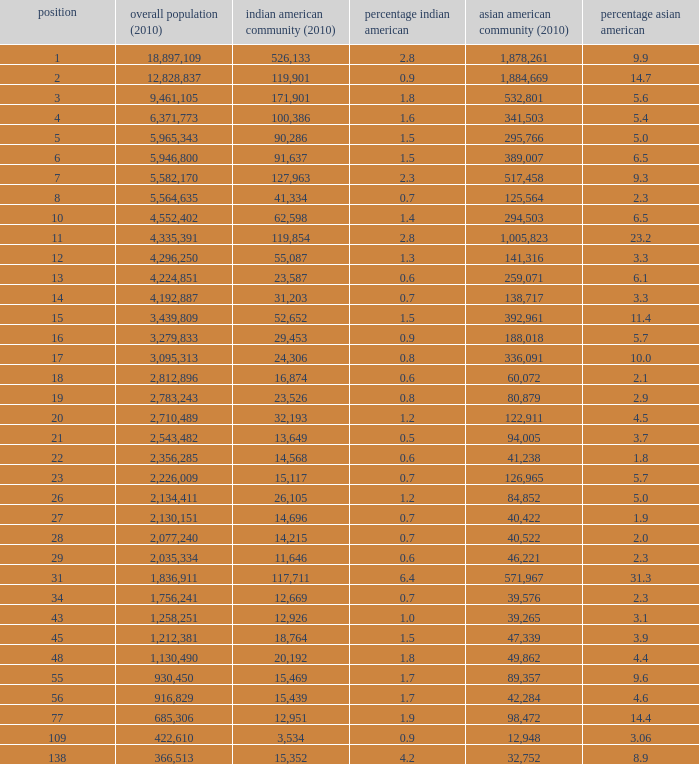What's the total population when there are 5.7% Asian American and fewer than 126,965 Asian American Population? None. 